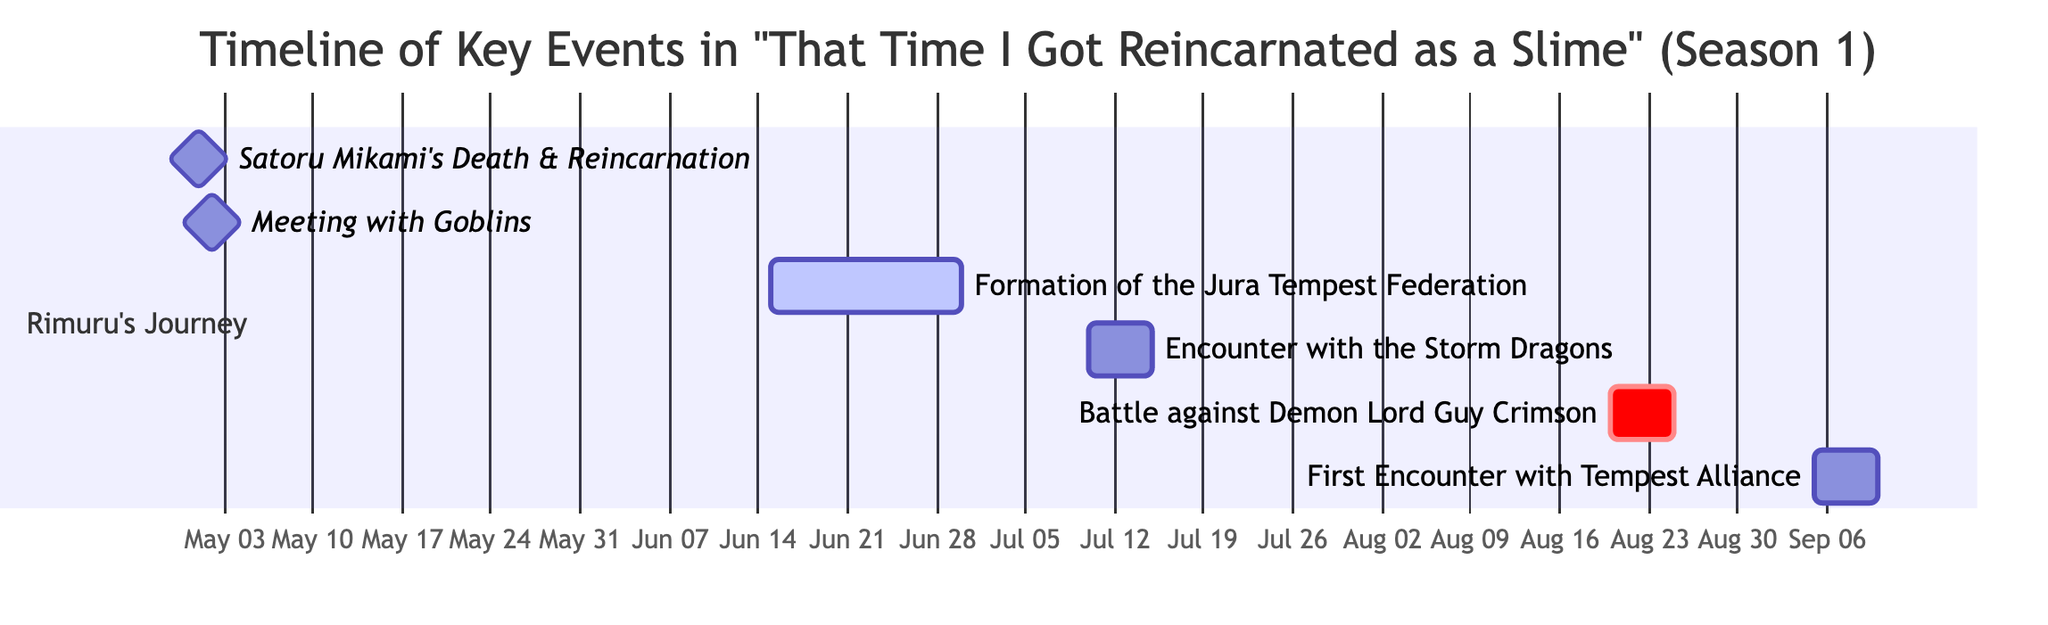What is the first event listed in the timeline? The first event in the timeline is "Satoru Mikami's Death," which is displayed at the top of the Gantt chart.
Answer: Satoru Mikami's Death How many days did the formation of the Jura Tempest Federation take? The formation of the Jura Tempest Federation is shown to span from June 15 to June 30, which is a total of 15 days in the Gantt chart.
Answer: 15 days What event occurs immediately after the "Meeting with Goblins"? The event that follows immediately after the "Meeting with Goblins," which occurs on May 2, is the "Formation of the Jura Tempest Federation," which starts on June 15.
Answer: Formation of the Jura Tempest Federation When does the Battle against the Demon Lord Guy Crimson take place? The Gantt chart indicates that the Battle against the Demon Lord Guy Crimson takes place from August 20 to August 25, as displayed in the corresponding timeline section.
Answer: August 20 to August 25 What is the total number of events represented in the Gantt chart? By counting each distinct event listed in the Gantt chart, there are a total of 6 events represented: Satoru Mikami's Death, Reincarnation as Rimuru Tempest, Meeting with Goblins, Formation of the Jura Tempest Federation, Encounter with the Storm Dragons, and Battle against Demon Lord Guy Crimson, along with the First Encounter with Tempest Alliance.
Answer: 6 events 